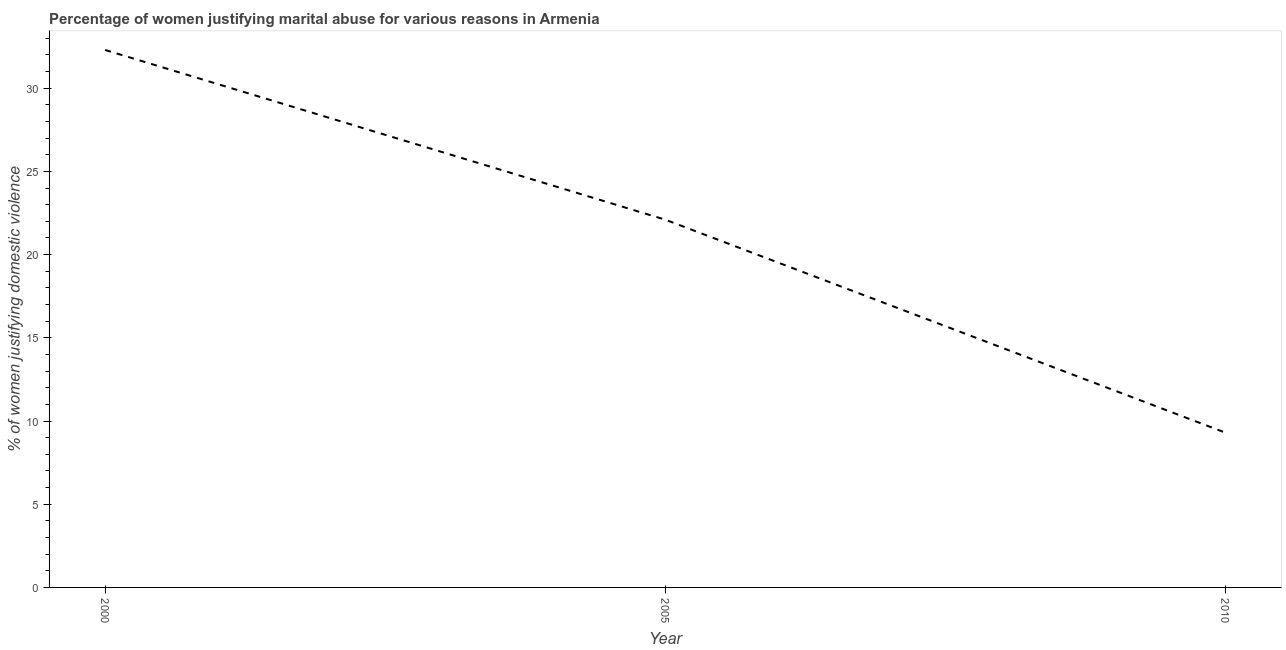What is the percentage of women justifying marital abuse in 2000?
Your answer should be compact. 32.3. Across all years, what is the maximum percentage of women justifying marital abuse?
Give a very brief answer. 32.3. Across all years, what is the minimum percentage of women justifying marital abuse?
Offer a very short reply. 9.3. In which year was the percentage of women justifying marital abuse maximum?
Offer a terse response. 2000. In which year was the percentage of women justifying marital abuse minimum?
Provide a short and direct response. 2010. What is the sum of the percentage of women justifying marital abuse?
Ensure brevity in your answer.  63.7. What is the average percentage of women justifying marital abuse per year?
Ensure brevity in your answer.  21.23. What is the median percentage of women justifying marital abuse?
Offer a terse response. 22.1. In how many years, is the percentage of women justifying marital abuse greater than 16 %?
Offer a very short reply. 2. Do a majority of the years between 2010 and 2000 (inclusive) have percentage of women justifying marital abuse greater than 6 %?
Keep it short and to the point. No. What is the ratio of the percentage of women justifying marital abuse in 2000 to that in 2005?
Make the answer very short. 1.46. Is the percentage of women justifying marital abuse in 2005 less than that in 2010?
Ensure brevity in your answer.  No. What is the difference between the highest and the second highest percentage of women justifying marital abuse?
Make the answer very short. 10.2. Is the sum of the percentage of women justifying marital abuse in 2005 and 2010 greater than the maximum percentage of women justifying marital abuse across all years?
Give a very brief answer. No. What is the difference between the highest and the lowest percentage of women justifying marital abuse?
Offer a terse response. 23. In how many years, is the percentage of women justifying marital abuse greater than the average percentage of women justifying marital abuse taken over all years?
Your response must be concise. 2. How many lines are there?
Your answer should be very brief. 1. What is the difference between two consecutive major ticks on the Y-axis?
Make the answer very short. 5. Does the graph contain grids?
Provide a succinct answer. No. What is the title of the graph?
Offer a terse response. Percentage of women justifying marital abuse for various reasons in Armenia. What is the label or title of the Y-axis?
Make the answer very short. % of women justifying domestic violence. What is the % of women justifying domestic violence of 2000?
Your answer should be very brief. 32.3. What is the % of women justifying domestic violence in 2005?
Offer a very short reply. 22.1. What is the % of women justifying domestic violence in 2010?
Your answer should be very brief. 9.3. What is the difference between the % of women justifying domestic violence in 2000 and 2005?
Keep it short and to the point. 10.2. What is the difference between the % of women justifying domestic violence in 2005 and 2010?
Your answer should be very brief. 12.8. What is the ratio of the % of women justifying domestic violence in 2000 to that in 2005?
Your answer should be very brief. 1.46. What is the ratio of the % of women justifying domestic violence in 2000 to that in 2010?
Provide a short and direct response. 3.47. What is the ratio of the % of women justifying domestic violence in 2005 to that in 2010?
Provide a short and direct response. 2.38. 